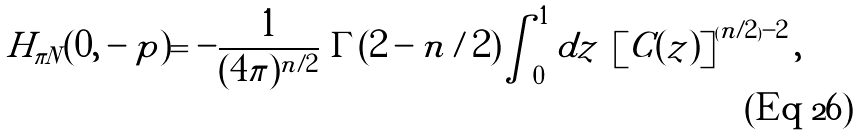<formula> <loc_0><loc_0><loc_500><loc_500>H _ { { \pi } N } ( 0 , - p ) = - \frac { 1 } { ( 4 \pi ) ^ { n / 2 } } \ \Gamma ( 2 - n / 2 ) \int _ { 0 } ^ { 1 } d z \ \left [ C ( z ) \right ] ^ { ( n / 2 ) - 2 } ,</formula> 